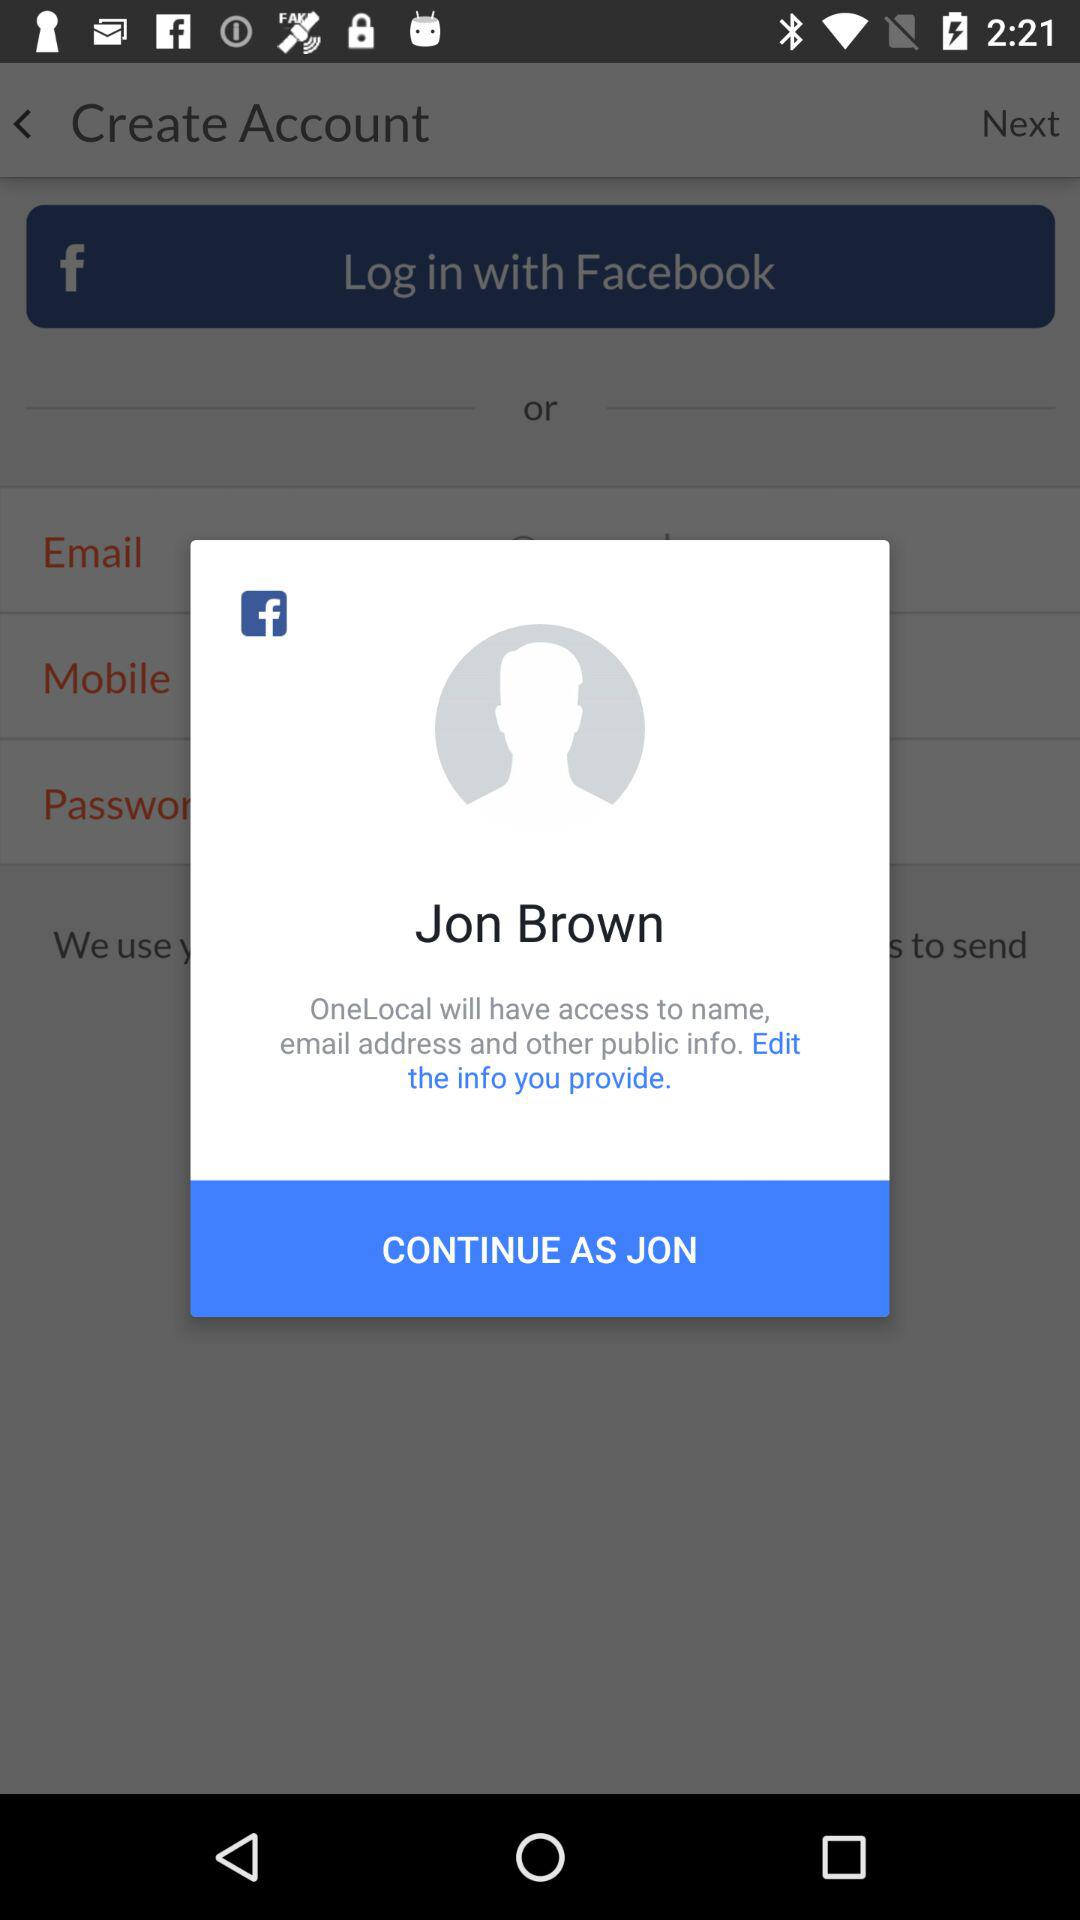What application is asking for permission? The application asking for permission is "OneLocal". 